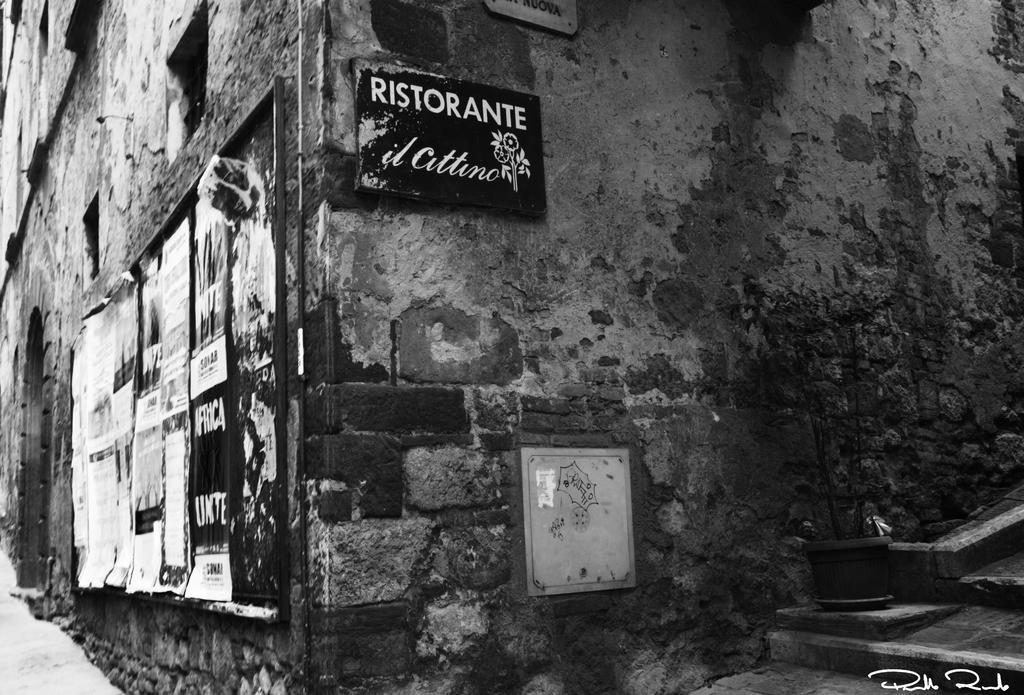Can you describe this image briefly? This is a black and white image. In this image we can see a building. On the building there is a board with posters. On the right side there is a pot with a plant. On the wall there are posters. And there is a watermark in the right bottom corner. 